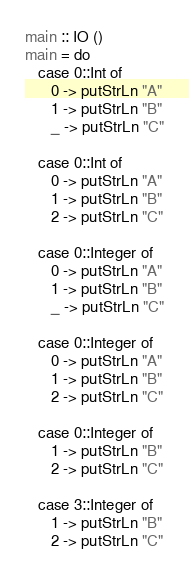<code> <loc_0><loc_0><loc_500><loc_500><_Haskell_>main :: IO ()
main = do
   case 0::Int of
      0 -> putStrLn "A"
      1 -> putStrLn "B"
      _ -> putStrLn "C"

   case 0::Int of
      0 -> putStrLn "A"
      1 -> putStrLn "B"
      2 -> putStrLn "C"

   case 0::Integer of
      0 -> putStrLn "A"
      1 -> putStrLn "B"
      _ -> putStrLn "C"

   case 0::Integer of
      0 -> putStrLn "A"
      1 -> putStrLn "B"
      2 -> putStrLn "C"

   case 0::Integer of
      1 -> putStrLn "B"
      2 -> putStrLn "C"

   case 3::Integer of
      1 -> putStrLn "B"
      2 -> putStrLn "C"
</code> 